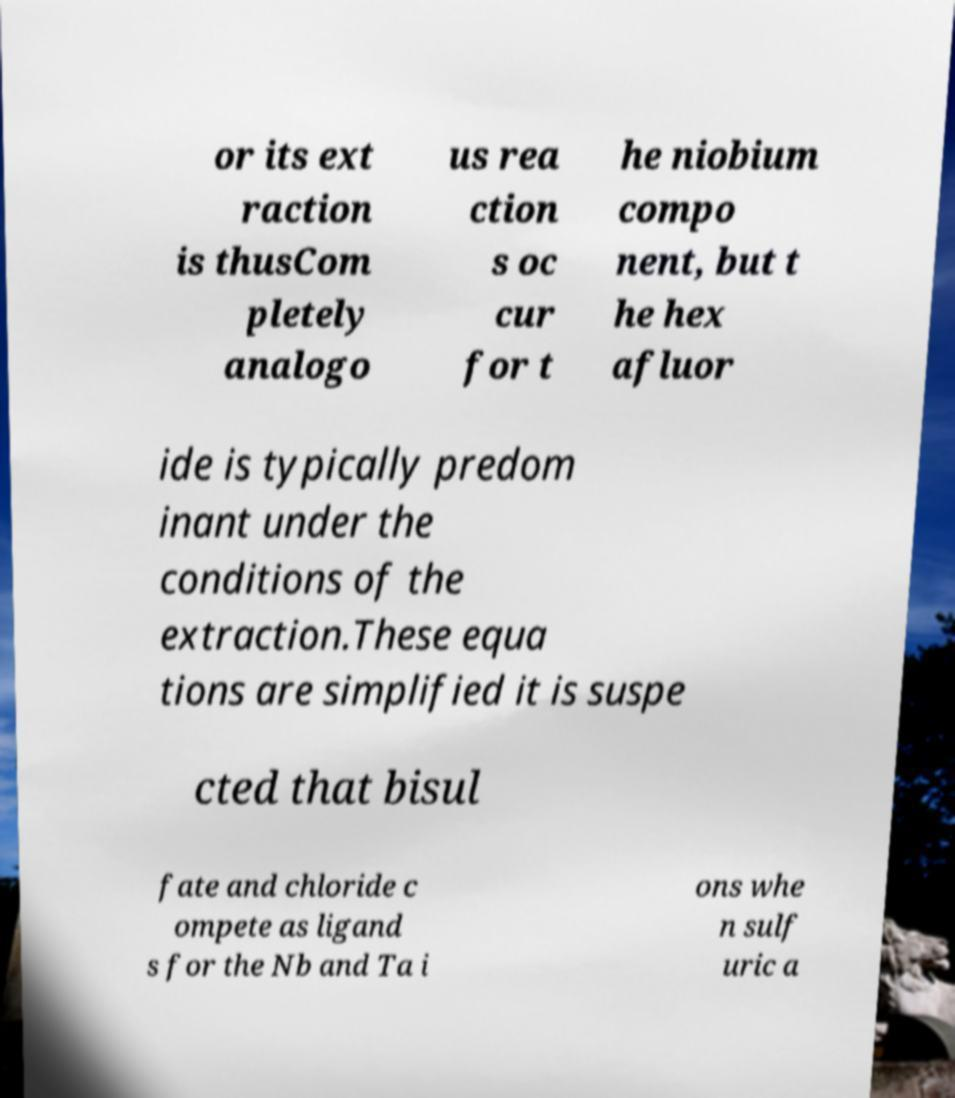I need the written content from this picture converted into text. Can you do that? or its ext raction is thusCom pletely analogo us rea ction s oc cur for t he niobium compo nent, but t he hex afluor ide is typically predom inant under the conditions of the extraction.These equa tions are simplified it is suspe cted that bisul fate and chloride c ompete as ligand s for the Nb and Ta i ons whe n sulf uric a 